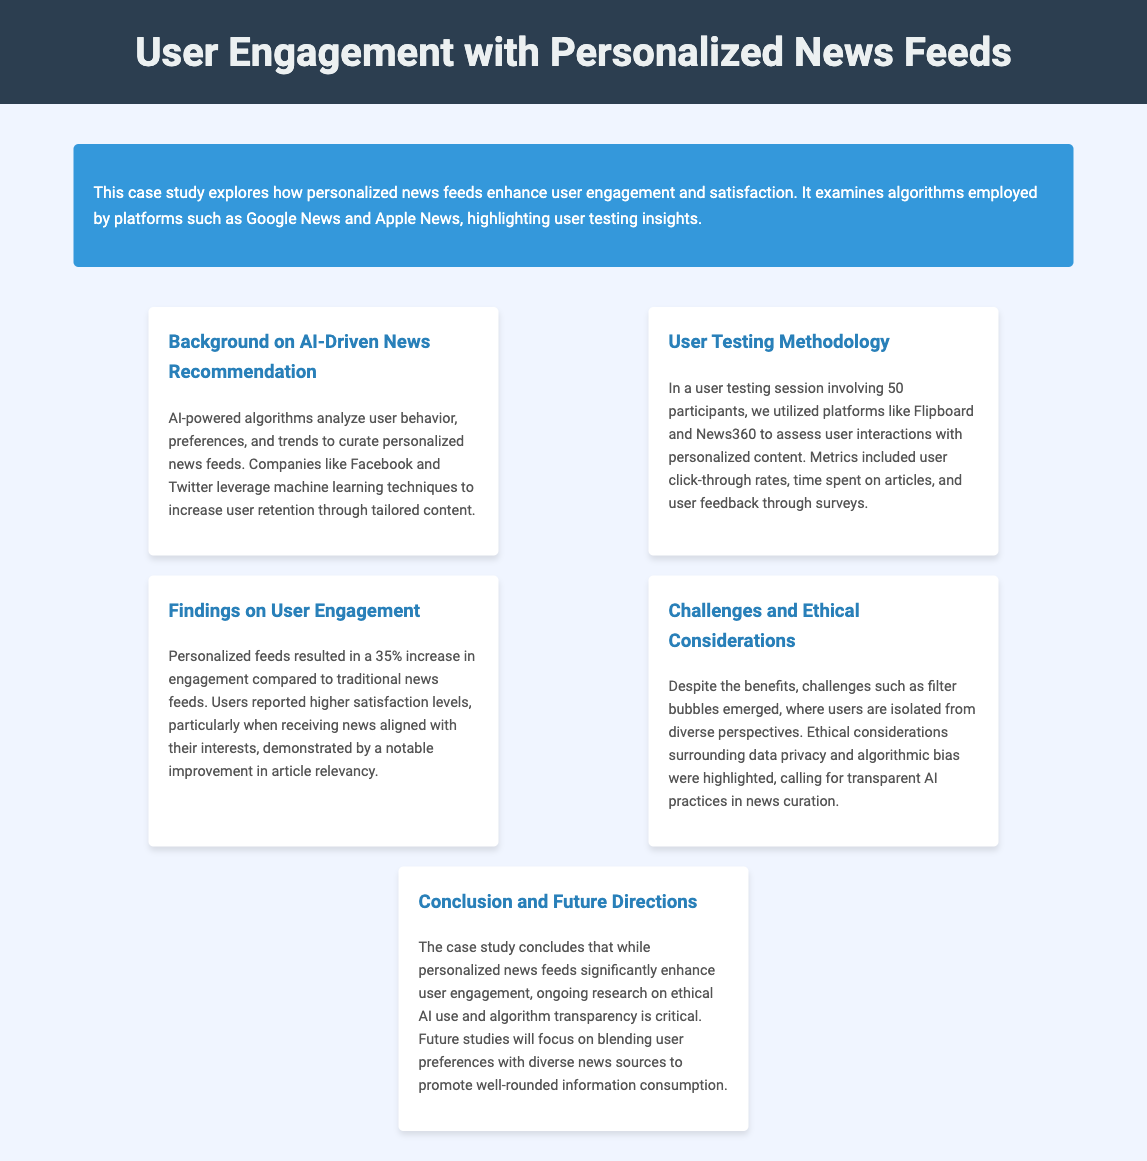What is the primary focus of the case study? The case study primarily focuses on how personalized news feeds enhance user engagement and satisfaction.
Answer: User engagement and satisfaction What percentage increase in engagement was reported with personalized feeds? The document states that personalized feeds resulted in a 35% increase in engagement compared to traditional news feeds.
Answer: 35% How many participants were involved in the user testing session? The user testing session involved 50 participants to assess interactions with personalized content.
Answer: 50 What ethical challenges are highlighted in the study? The study highlights challenges such as filter bubbles and ethical considerations surrounding data privacy and algorithmic bias.
Answer: Filter bubbles Which companies utilize AI-powered algorithms for news recommendations? The document mentions companies like Facebook and Twitter that use AI-powered algorithms for personalized news feeds.
Answer: Facebook and Twitter What is the conclusion regarding the future direction of research in this study? The conclusion suggests that future studies will focus on blending user preferences with diverse news sources.
Answer: Blending user preferences with diverse news sources 